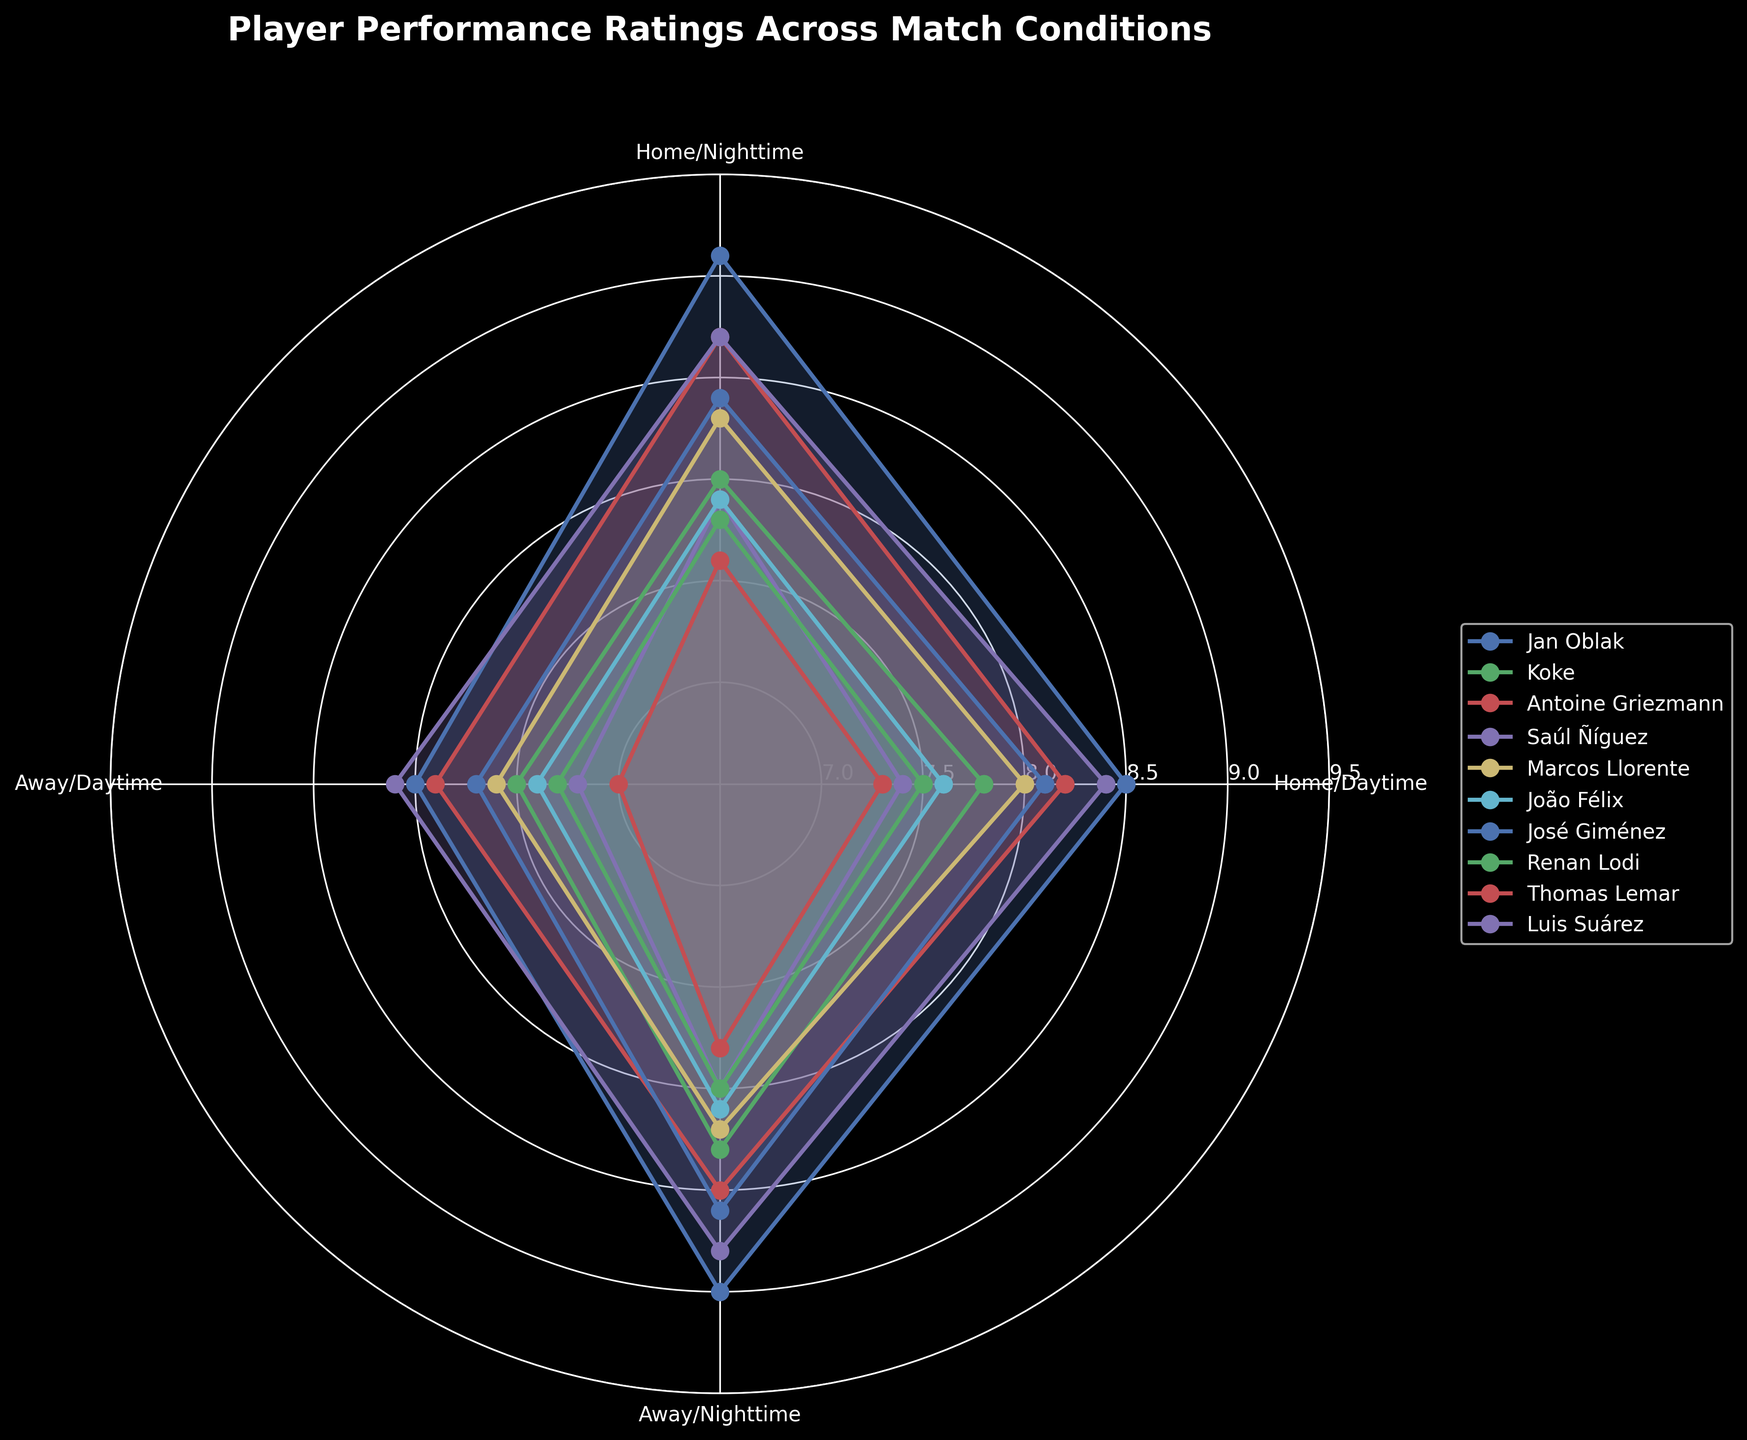What is the title of the chart? The title of the chart is located at the top and is typically the most prominent text element in the figure.
Answer: Player Performance Ratings Across Match Conditions Which player has the highest performance rating during nighttime away conditions? Look for the player's line with the highest value in the sector corresponding to nighttime away conditions.
Answer: Luis Suárez What is the average performance rating of Koke across all match conditions? Sum Koke's ratings: (7.8 + 8.0 + 7.5 + 8.3 = 31.6). Divide by the number of conditions (4).
Answer: 7.9 How do João Félix's performance ratings compare between home daytime and away nighttime conditions? Look at João Félix's ratings in the sectors for home daytime (7.6) and away nighttime (8.1). Compare the two values.
Answer: Away nighttime is higher by 0.5 Which player shows the least variation in performance ratings across the different conditions? Examine the range (difference between highest and lowest ratings) for each player. Identify the player with the smallest range.
Answer: Antoine Griezmann (1.3) Which condition generally has the highest average player performance rating? Calculate the average rating for each condition by summing the ratings across all players for each condition and divide by the number of players (10).
Answer: Home Nighttime Which two players have the most similar performance ratings in home daytime conditions? Compare the ratings in the sector for home daytime for all players and find the pair with the smallest difference.
Answer: Marcos Llorente and João Félix (0.4) What is the total performance rating of Jan Oblak and Koke during home nighttime conditions? Add the performance ratings of Jan Oblak (9.1) and Koke (8.0) for home nighttime conditions.
Answer: 17.1 Who has a higher average performance during any conditions: Saúl Ñíguez or Thomas Lemar? Calculate the average ratings for Saúl Ñíguez (7.4 + 7.9 + 7.2 + 8.0 = 30.5)/4 = 7.625 and Thomas Lemar (7.3 + 7.6 + 7.0 + 7.8 = 29.7)/4 = 7.425. Compare the averages.
Answer: Saúl Ñíguez What is the median performance rating of Antoine Griezmann across all match conditions? Sort Antoine Griezmann's ratings (7.9, 8.2, 8.5, 8.7). The median is the average of the two middle values.
Answer: 8.35 